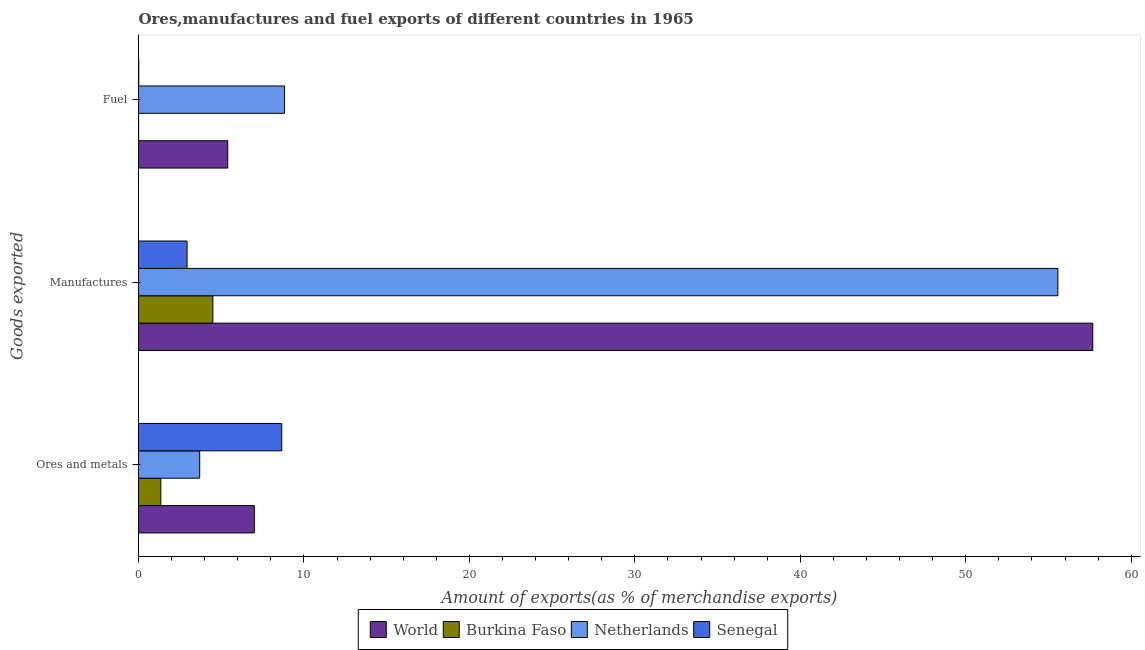How many bars are there on the 2nd tick from the top?
Provide a short and direct response. 4. What is the label of the 2nd group of bars from the top?
Ensure brevity in your answer.  Manufactures. What is the percentage of fuel exports in Netherlands?
Give a very brief answer. 8.83. Across all countries, what is the maximum percentage of ores and metals exports?
Your answer should be very brief. 8.66. Across all countries, what is the minimum percentage of ores and metals exports?
Provide a succinct answer. 1.35. In which country was the percentage of manufactures exports maximum?
Your answer should be very brief. World. In which country was the percentage of manufactures exports minimum?
Ensure brevity in your answer.  Senegal. What is the total percentage of manufactures exports in the graph?
Your answer should be compact. 120.67. What is the difference between the percentage of ores and metals exports in Netherlands and that in World?
Give a very brief answer. -3.3. What is the difference between the percentage of manufactures exports in World and the percentage of ores and metals exports in Senegal?
Give a very brief answer. 49.02. What is the average percentage of fuel exports per country?
Ensure brevity in your answer.  3.56. What is the difference between the percentage of fuel exports and percentage of manufactures exports in Senegal?
Keep it short and to the point. -2.92. In how many countries, is the percentage of fuel exports greater than 20 %?
Provide a short and direct response. 0. What is the ratio of the percentage of manufactures exports in World to that in Burkina Faso?
Your response must be concise. 12.83. Is the difference between the percentage of ores and metals exports in Burkina Faso and Netherlands greater than the difference between the percentage of manufactures exports in Burkina Faso and Netherlands?
Your answer should be compact. Yes. What is the difference between the highest and the second highest percentage of fuel exports?
Make the answer very short. 3.43. What is the difference between the highest and the lowest percentage of fuel exports?
Make the answer very short. 8.82. What does the 1st bar from the top in Ores and metals represents?
Offer a very short reply. Senegal. What does the 4th bar from the bottom in Ores and metals represents?
Keep it short and to the point. Senegal. Is it the case that in every country, the sum of the percentage of ores and metals exports and percentage of manufactures exports is greater than the percentage of fuel exports?
Ensure brevity in your answer.  Yes. How many bars are there?
Give a very brief answer. 12. How many countries are there in the graph?
Your answer should be compact. 4. What is the difference between two consecutive major ticks on the X-axis?
Your answer should be very brief. 10. Does the graph contain any zero values?
Your answer should be compact. No. Does the graph contain grids?
Provide a succinct answer. No. How many legend labels are there?
Provide a succinct answer. 4. How are the legend labels stacked?
Your answer should be very brief. Horizontal. What is the title of the graph?
Your answer should be very brief. Ores,manufactures and fuel exports of different countries in 1965. What is the label or title of the X-axis?
Offer a terse response. Amount of exports(as % of merchandise exports). What is the label or title of the Y-axis?
Your answer should be compact. Goods exported. What is the Amount of exports(as % of merchandise exports) of World in Ores and metals?
Ensure brevity in your answer.  7. What is the Amount of exports(as % of merchandise exports) of Burkina Faso in Ores and metals?
Make the answer very short. 1.35. What is the Amount of exports(as % of merchandise exports) of Netherlands in Ores and metals?
Provide a succinct answer. 3.7. What is the Amount of exports(as % of merchandise exports) of Senegal in Ores and metals?
Offer a terse response. 8.66. What is the Amount of exports(as % of merchandise exports) in World in Manufactures?
Your answer should be very brief. 57.68. What is the Amount of exports(as % of merchandise exports) of Burkina Faso in Manufactures?
Ensure brevity in your answer.  4.49. What is the Amount of exports(as % of merchandise exports) in Netherlands in Manufactures?
Your response must be concise. 55.57. What is the Amount of exports(as % of merchandise exports) of Senegal in Manufactures?
Your response must be concise. 2.93. What is the Amount of exports(as % of merchandise exports) of World in Fuel?
Offer a terse response. 5.39. What is the Amount of exports(as % of merchandise exports) of Burkina Faso in Fuel?
Your answer should be very brief. 0.01. What is the Amount of exports(as % of merchandise exports) of Netherlands in Fuel?
Make the answer very short. 8.83. What is the Amount of exports(as % of merchandise exports) in Senegal in Fuel?
Your response must be concise. 0.01. Across all Goods exported, what is the maximum Amount of exports(as % of merchandise exports) in World?
Provide a succinct answer. 57.68. Across all Goods exported, what is the maximum Amount of exports(as % of merchandise exports) in Burkina Faso?
Your response must be concise. 4.49. Across all Goods exported, what is the maximum Amount of exports(as % of merchandise exports) of Netherlands?
Offer a very short reply. 55.57. Across all Goods exported, what is the maximum Amount of exports(as % of merchandise exports) in Senegal?
Provide a succinct answer. 8.66. Across all Goods exported, what is the minimum Amount of exports(as % of merchandise exports) of World?
Offer a very short reply. 5.39. Across all Goods exported, what is the minimum Amount of exports(as % of merchandise exports) in Burkina Faso?
Provide a succinct answer. 0.01. Across all Goods exported, what is the minimum Amount of exports(as % of merchandise exports) in Netherlands?
Give a very brief answer. 3.7. Across all Goods exported, what is the minimum Amount of exports(as % of merchandise exports) of Senegal?
Offer a terse response. 0.01. What is the total Amount of exports(as % of merchandise exports) in World in the graph?
Provide a succinct answer. 70.07. What is the total Amount of exports(as % of merchandise exports) of Burkina Faso in the graph?
Provide a succinct answer. 5.85. What is the total Amount of exports(as % of merchandise exports) in Netherlands in the graph?
Ensure brevity in your answer.  68.09. What is the total Amount of exports(as % of merchandise exports) of Senegal in the graph?
Provide a succinct answer. 11.61. What is the difference between the Amount of exports(as % of merchandise exports) of World in Ores and metals and that in Manufactures?
Ensure brevity in your answer.  -50.68. What is the difference between the Amount of exports(as % of merchandise exports) in Burkina Faso in Ores and metals and that in Manufactures?
Ensure brevity in your answer.  -3.15. What is the difference between the Amount of exports(as % of merchandise exports) of Netherlands in Ores and metals and that in Manufactures?
Ensure brevity in your answer.  -51.87. What is the difference between the Amount of exports(as % of merchandise exports) in Senegal in Ores and metals and that in Manufactures?
Ensure brevity in your answer.  5.72. What is the difference between the Amount of exports(as % of merchandise exports) of World in Ores and metals and that in Fuel?
Provide a succinct answer. 1.61. What is the difference between the Amount of exports(as % of merchandise exports) in Burkina Faso in Ores and metals and that in Fuel?
Offer a very short reply. 1.34. What is the difference between the Amount of exports(as % of merchandise exports) in Netherlands in Ores and metals and that in Fuel?
Make the answer very short. -5.13. What is the difference between the Amount of exports(as % of merchandise exports) of Senegal in Ores and metals and that in Fuel?
Offer a very short reply. 8.64. What is the difference between the Amount of exports(as % of merchandise exports) in World in Manufactures and that in Fuel?
Your answer should be very brief. 52.28. What is the difference between the Amount of exports(as % of merchandise exports) of Burkina Faso in Manufactures and that in Fuel?
Offer a terse response. 4.49. What is the difference between the Amount of exports(as % of merchandise exports) of Netherlands in Manufactures and that in Fuel?
Your answer should be compact. 46.74. What is the difference between the Amount of exports(as % of merchandise exports) of Senegal in Manufactures and that in Fuel?
Your answer should be very brief. 2.92. What is the difference between the Amount of exports(as % of merchandise exports) in World in Ores and metals and the Amount of exports(as % of merchandise exports) in Burkina Faso in Manufactures?
Keep it short and to the point. 2.51. What is the difference between the Amount of exports(as % of merchandise exports) in World in Ores and metals and the Amount of exports(as % of merchandise exports) in Netherlands in Manufactures?
Provide a short and direct response. -48.57. What is the difference between the Amount of exports(as % of merchandise exports) of World in Ores and metals and the Amount of exports(as % of merchandise exports) of Senegal in Manufactures?
Offer a terse response. 4.07. What is the difference between the Amount of exports(as % of merchandise exports) in Burkina Faso in Ores and metals and the Amount of exports(as % of merchandise exports) in Netherlands in Manufactures?
Keep it short and to the point. -54.22. What is the difference between the Amount of exports(as % of merchandise exports) of Burkina Faso in Ores and metals and the Amount of exports(as % of merchandise exports) of Senegal in Manufactures?
Give a very brief answer. -1.59. What is the difference between the Amount of exports(as % of merchandise exports) in Netherlands in Ores and metals and the Amount of exports(as % of merchandise exports) in Senegal in Manufactures?
Give a very brief answer. 0.76. What is the difference between the Amount of exports(as % of merchandise exports) of World in Ores and metals and the Amount of exports(as % of merchandise exports) of Burkina Faso in Fuel?
Keep it short and to the point. 6.99. What is the difference between the Amount of exports(as % of merchandise exports) of World in Ores and metals and the Amount of exports(as % of merchandise exports) of Netherlands in Fuel?
Offer a very short reply. -1.83. What is the difference between the Amount of exports(as % of merchandise exports) in World in Ores and metals and the Amount of exports(as % of merchandise exports) in Senegal in Fuel?
Your response must be concise. 6.99. What is the difference between the Amount of exports(as % of merchandise exports) of Burkina Faso in Ores and metals and the Amount of exports(as % of merchandise exports) of Netherlands in Fuel?
Give a very brief answer. -7.48. What is the difference between the Amount of exports(as % of merchandise exports) of Burkina Faso in Ores and metals and the Amount of exports(as % of merchandise exports) of Senegal in Fuel?
Your answer should be compact. 1.33. What is the difference between the Amount of exports(as % of merchandise exports) in Netherlands in Ores and metals and the Amount of exports(as % of merchandise exports) in Senegal in Fuel?
Your answer should be compact. 3.68. What is the difference between the Amount of exports(as % of merchandise exports) in World in Manufactures and the Amount of exports(as % of merchandise exports) in Burkina Faso in Fuel?
Provide a short and direct response. 57.67. What is the difference between the Amount of exports(as % of merchandise exports) of World in Manufactures and the Amount of exports(as % of merchandise exports) of Netherlands in Fuel?
Provide a succinct answer. 48.85. What is the difference between the Amount of exports(as % of merchandise exports) of World in Manufactures and the Amount of exports(as % of merchandise exports) of Senegal in Fuel?
Your answer should be compact. 57.66. What is the difference between the Amount of exports(as % of merchandise exports) of Burkina Faso in Manufactures and the Amount of exports(as % of merchandise exports) of Netherlands in Fuel?
Provide a short and direct response. -4.33. What is the difference between the Amount of exports(as % of merchandise exports) in Burkina Faso in Manufactures and the Amount of exports(as % of merchandise exports) in Senegal in Fuel?
Your answer should be very brief. 4.48. What is the difference between the Amount of exports(as % of merchandise exports) of Netherlands in Manufactures and the Amount of exports(as % of merchandise exports) of Senegal in Fuel?
Provide a short and direct response. 55.55. What is the average Amount of exports(as % of merchandise exports) in World per Goods exported?
Your answer should be compact. 23.36. What is the average Amount of exports(as % of merchandise exports) in Burkina Faso per Goods exported?
Give a very brief answer. 1.95. What is the average Amount of exports(as % of merchandise exports) of Netherlands per Goods exported?
Offer a terse response. 22.7. What is the average Amount of exports(as % of merchandise exports) in Senegal per Goods exported?
Provide a short and direct response. 3.87. What is the difference between the Amount of exports(as % of merchandise exports) of World and Amount of exports(as % of merchandise exports) of Burkina Faso in Ores and metals?
Offer a terse response. 5.65. What is the difference between the Amount of exports(as % of merchandise exports) in World and Amount of exports(as % of merchandise exports) in Netherlands in Ores and metals?
Offer a very short reply. 3.3. What is the difference between the Amount of exports(as % of merchandise exports) in World and Amount of exports(as % of merchandise exports) in Senegal in Ores and metals?
Your response must be concise. -1.66. What is the difference between the Amount of exports(as % of merchandise exports) of Burkina Faso and Amount of exports(as % of merchandise exports) of Netherlands in Ores and metals?
Ensure brevity in your answer.  -2.35. What is the difference between the Amount of exports(as % of merchandise exports) of Burkina Faso and Amount of exports(as % of merchandise exports) of Senegal in Ores and metals?
Offer a very short reply. -7.31. What is the difference between the Amount of exports(as % of merchandise exports) of Netherlands and Amount of exports(as % of merchandise exports) of Senegal in Ores and metals?
Provide a short and direct response. -4.96. What is the difference between the Amount of exports(as % of merchandise exports) of World and Amount of exports(as % of merchandise exports) of Burkina Faso in Manufactures?
Your answer should be very brief. 53.18. What is the difference between the Amount of exports(as % of merchandise exports) of World and Amount of exports(as % of merchandise exports) of Netherlands in Manufactures?
Make the answer very short. 2.11. What is the difference between the Amount of exports(as % of merchandise exports) of World and Amount of exports(as % of merchandise exports) of Senegal in Manufactures?
Keep it short and to the point. 54.74. What is the difference between the Amount of exports(as % of merchandise exports) of Burkina Faso and Amount of exports(as % of merchandise exports) of Netherlands in Manufactures?
Offer a very short reply. -51.07. What is the difference between the Amount of exports(as % of merchandise exports) in Burkina Faso and Amount of exports(as % of merchandise exports) in Senegal in Manufactures?
Offer a very short reply. 1.56. What is the difference between the Amount of exports(as % of merchandise exports) in Netherlands and Amount of exports(as % of merchandise exports) in Senegal in Manufactures?
Keep it short and to the point. 52.63. What is the difference between the Amount of exports(as % of merchandise exports) of World and Amount of exports(as % of merchandise exports) of Burkina Faso in Fuel?
Offer a terse response. 5.39. What is the difference between the Amount of exports(as % of merchandise exports) in World and Amount of exports(as % of merchandise exports) in Netherlands in Fuel?
Make the answer very short. -3.43. What is the difference between the Amount of exports(as % of merchandise exports) in World and Amount of exports(as % of merchandise exports) in Senegal in Fuel?
Provide a short and direct response. 5.38. What is the difference between the Amount of exports(as % of merchandise exports) of Burkina Faso and Amount of exports(as % of merchandise exports) of Netherlands in Fuel?
Ensure brevity in your answer.  -8.82. What is the difference between the Amount of exports(as % of merchandise exports) in Burkina Faso and Amount of exports(as % of merchandise exports) in Senegal in Fuel?
Offer a very short reply. -0.01. What is the difference between the Amount of exports(as % of merchandise exports) of Netherlands and Amount of exports(as % of merchandise exports) of Senegal in Fuel?
Offer a very short reply. 8.81. What is the ratio of the Amount of exports(as % of merchandise exports) in World in Ores and metals to that in Manufactures?
Your answer should be very brief. 0.12. What is the ratio of the Amount of exports(as % of merchandise exports) of Burkina Faso in Ores and metals to that in Manufactures?
Keep it short and to the point. 0.3. What is the ratio of the Amount of exports(as % of merchandise exports) in Netherlands in Ores and metals to that in Manufactures?
Ensure brevity in your answer.  0.07. What is the ratio of the Amount of exports(as % of merchandise exports) in Senegal in Ores and metals to that in Manufactures?
Make the answer very short. 2.95. What is the ratio of the Amount of exports(as % of merchandise exports) in World in Ores and metals to that in Fuel?
Ensure brevity in your answer.  1.3. What is the ratio of the Amount of exports(as % of merchandise exports) of Burkina Faso in Ores and metals to that in Fuel?
Your answer should be compact. 225.95. What is the ratio of the Amount of exports(as % of merchandise exports) in Netherlands in Ores and metals to that in Fuel?
Provide a short and direct response. 0.42. What is the ratio of the Amount of exports(as % of merchandise exports) in Senegal in Ores and metals to that in Fuel?
Your answer should be very brief. 590.43. What is the ratio of the Amount of exports(as % of merchandise exports) in World in Manufactures to that in Fuel?
Give a very brief answer. 10.69. What is the ratio of the Amount of exports(as % of merchandise exports) of Burkina Faso in Manufactures to that in Fuel?
Provide a succinct answer. 752.78. What is the ratio of the Amount of exports(as % of merchandise exports) of Netherlands in Manufactures to that in Fuel?
Offer a terse response. 6.3. What is the ratio of the Amount of exports(as % of merchandise exports) in Senegal in Manufactures to that in Fuel?
Your answer should be compact. 200.12. What is the difference between the highest and the second highest Amount of exports(as % of merchandise exports) of World?
Give a very brief answer. 50.68. What is the difference between the highest and the second highest Amount of exports(as % of merchandise exports) in Burkina Faso?
Offer a terse response. 3.15. What is the difference between the highest and the second highest Amount of exports(as % of merchandise exports) of Netherlands?
Give a very brief answer. 46.74. What is the difference between the highest and the second highest Amount of exports(as % of merchandise exports) of Senegal?
Give a very brief answer. 5.72. What is the difference between the highest and the lowest Amount of exports(as % of merchandise exports) in World?
Your answer should be compact. 52.28. What is the difference between the highest and the lowest Amount of exports(as % of merchandise exports) of Burkina Faso?
Keep it short and to the point. 4.49. What is the difference between the highest and the lowest Amount of exports(as % of merchandise exports) in Netherlands?
Your answer should be very brief. 51.87. What is the difference between the highest and the lowest Amount of exports(as % of merchandise exports) in Senegal?
Your response must be concise. 8.64. 